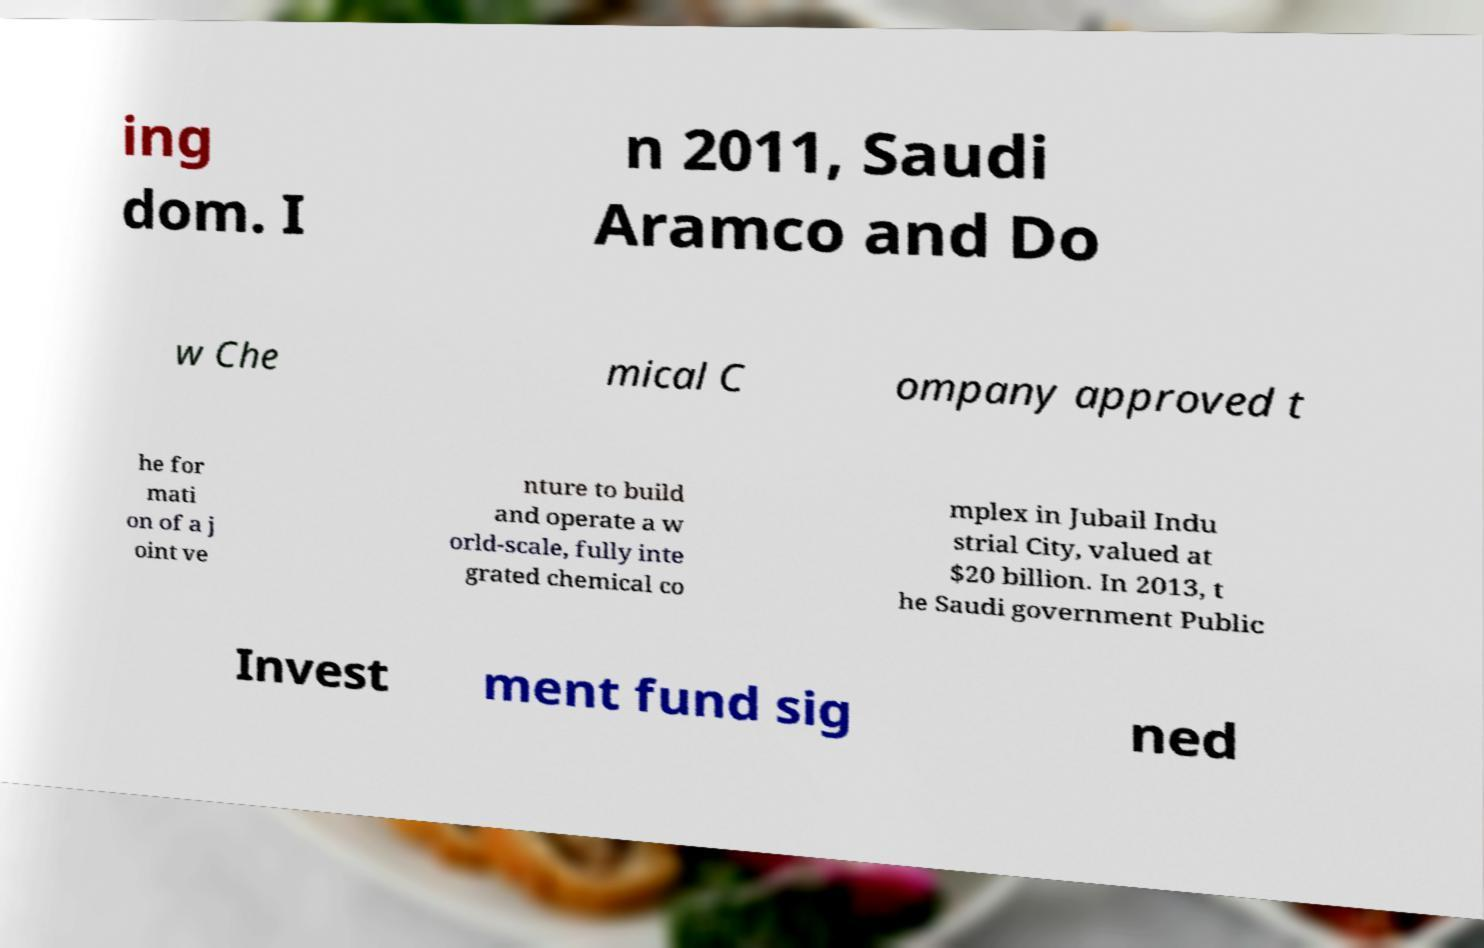Can you read and provide the text displayed in the image?This photo seems to have some interesting text. Can you extract and type it out for me? ing dom. I n 2011, Saudi Aramco and Do w Che mical C ompany approved t he for mati on of a j oint ve nture to build and operate a w orld-scale, fully inte grated chemical co mplex in Jubail Indu strial City, valued at $20 billion. In 2013, t he Saudi government Public Invest ment fund sig ned 